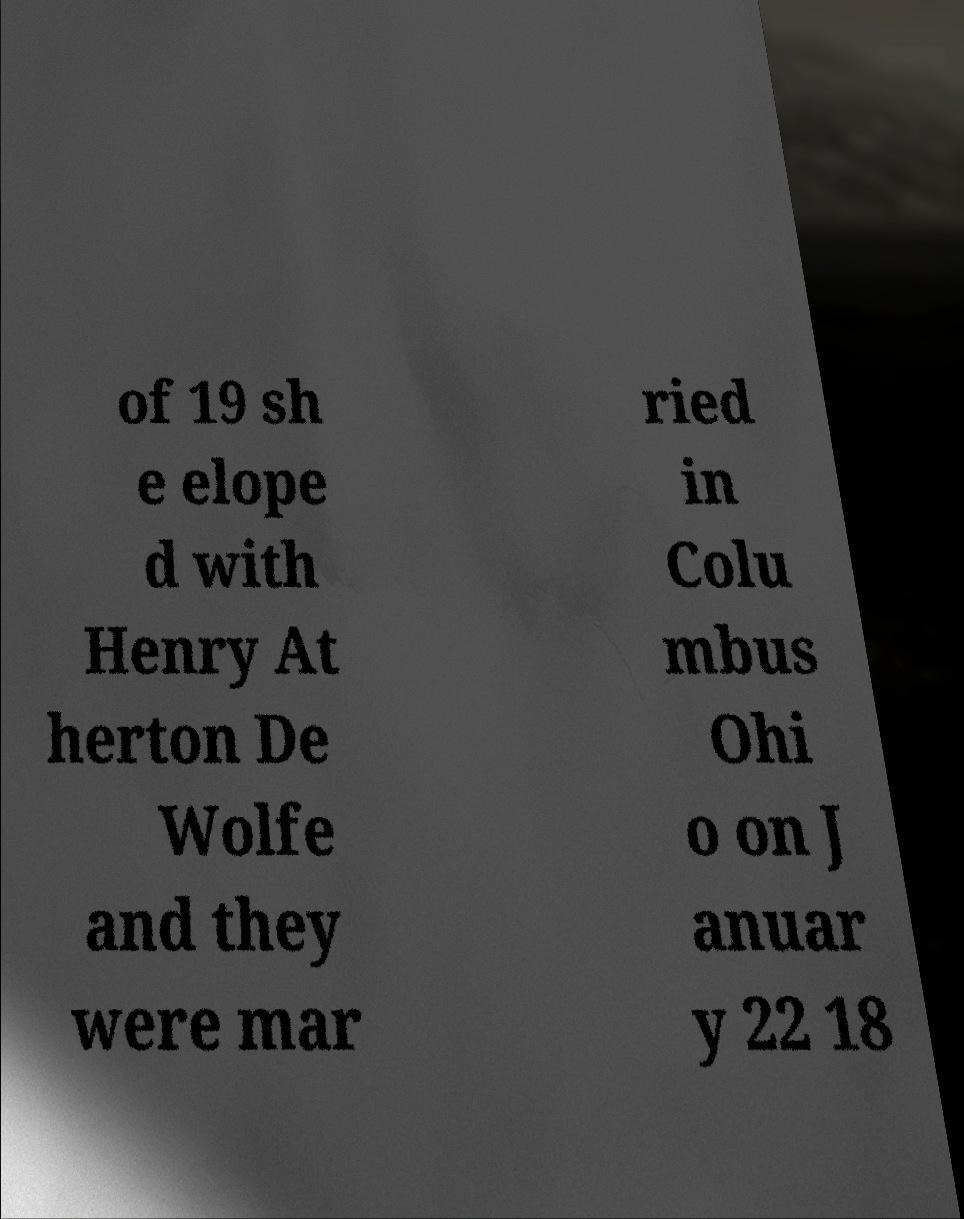Please read and relay the text visible in this image. What does it say? of 19 sh e elope d with Henry At herton De Wolfe and they were mar ried in Colu mbus Ohi o on J anuar y 22 18 